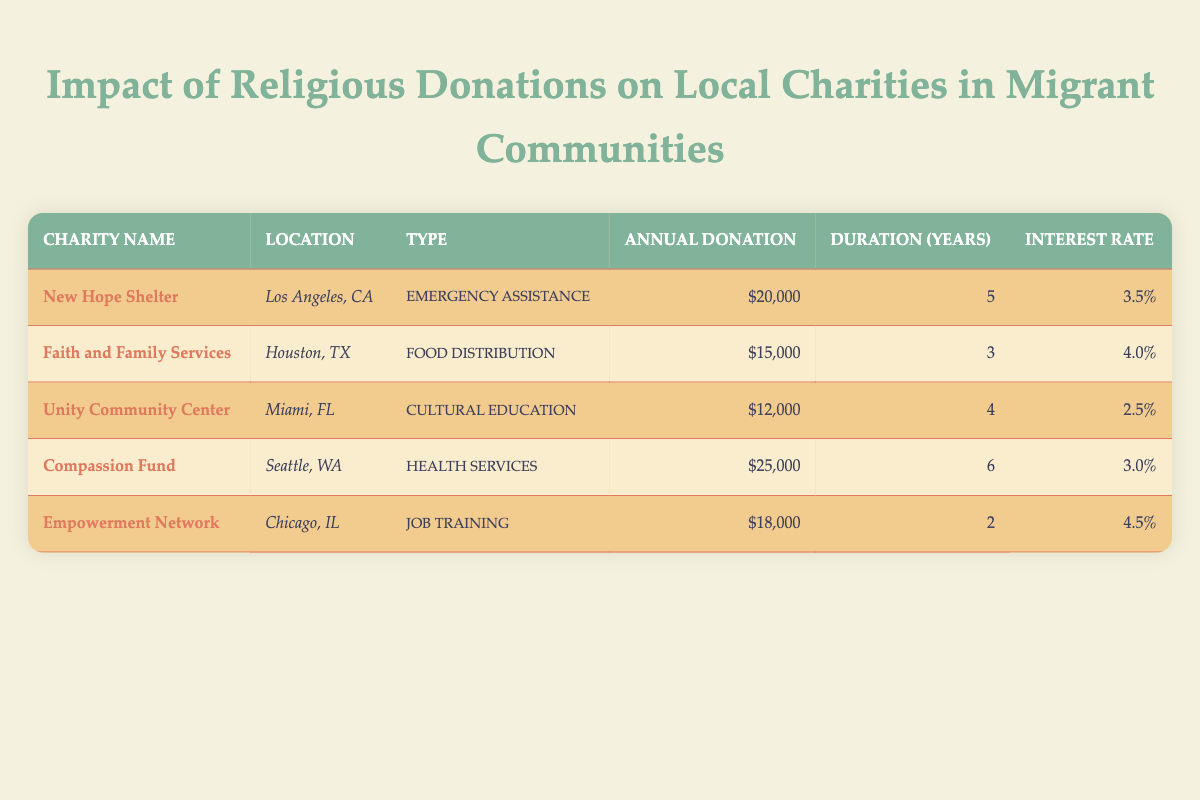What is the annual donation for the Compassion Fund? The table lists "Compassion Fund" with an annual donation of $25,000.
Answer: $25,000 Which charity has the highest interest rate on donations? By comparing the interest rates listed, "Empowerment Network" has the highest rate at 4.5%.
Answer: 4.5% What is the total annual donation amount across all charities? Adding the annual donations: 20000 + 15000 + 12000 + 25000 + 18000 = 110000. The total is $110,000.
Answer: $110,000 Is there any charity located in Miami, FL? The table shows "Unity Community Center" located in Miami, FL, confirming the presence of a charity there.
Answer: Yes What type of service does New Hope Shelter provide? The table states that "New Hope Shelter" provides "Emergency Assistance" as its service type.
Answer: Emergency Assistance What is the average duration of support for all charities? To calculate the average: (5 + 3 + 4 + 6 + 2) = 20 years. Dividing by the number of charities (5) gives an average of 20/5 = 4 years.
Answer: 4 years How many charities provide services related to food distribution? The table indicates that only "Faith and Family Services" provides "Food Distribution." Thus, there is one charity in this category.
Answer: 1 Which charity has the lowest annual donation, and what is it? The smallest annual donation is $12,000 attributed to "Unity Community Center."
Answer: $12,000 What is the combined interest rate of the Compassion Fund and Unity Community Center? The interest rates for the two charities are 3.0% for Compassion Fund and 2.5% for Unity Community Center. The combined rate is 3.0 + 2.5 = 5.5%.
Answer: 5.5% 